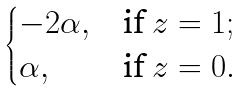Convert formula to latex. <formula><loc_0><loc_0><loc_500><loc_500>\begin{cases} - 2 \alpha , & \text {if } z = 1 ; \\ \alpha , & \text {if } z = 0 . \\ \end{cases}</formula> 